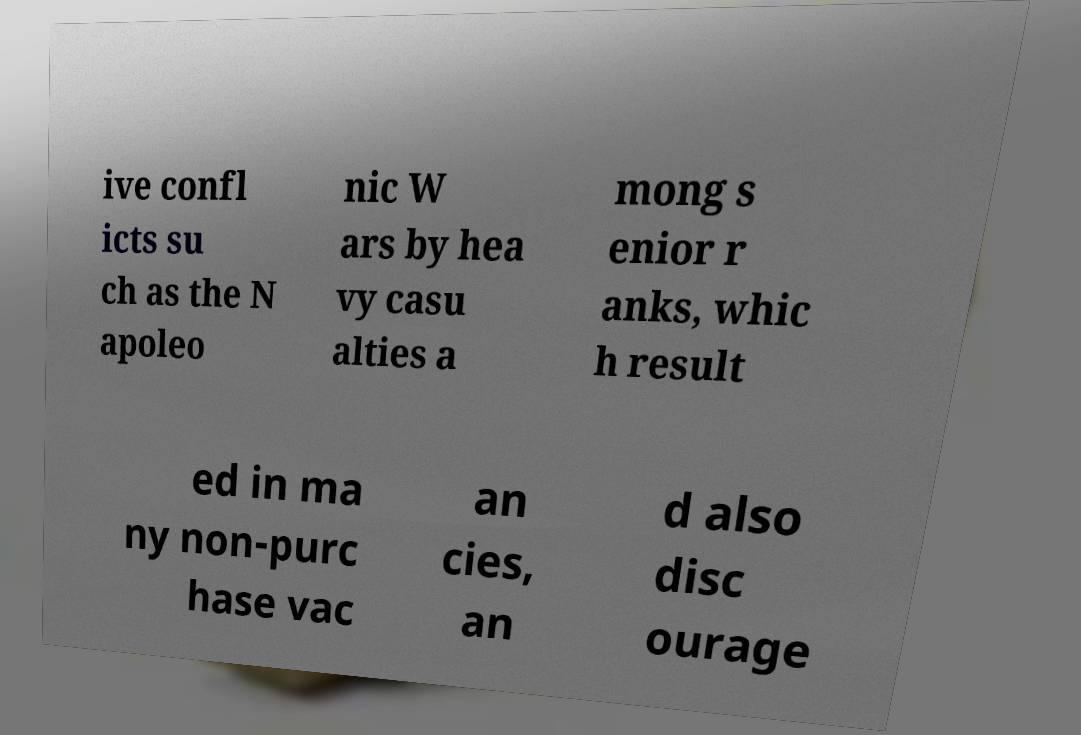Please identify and transcribe the text found in this image. ive confl icts su ch as the N apoleo nic W ars by hea vy casu alties a mong s enior r anks, whic h result ed in ma ny non-purc hase vac an cies, an d also disc ourage 